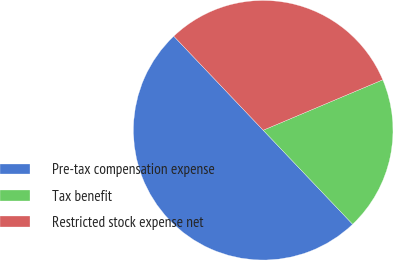<chart> <loc_0><loc_0><loc_500><loc_500><pie_chart><fcel>Pre-tax compensation expense<fcel>Tax benefit<fcel>Restricted stock expense net<nl><fcel>50.0%<fcel>19.25%<fcel>30.75%<nl></chart> 